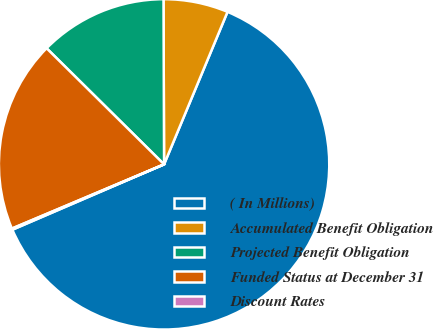Convert chart. <chart><loc_0><loc_0><loc_500><loc_500><pie_chart><fcel>( In Millions)<fcel>Accumulated Benefit Obligation<fcel>Projected Benefit Obligation<fcel>Funded Status at December 31<fcel>Discount Rates<nl><fcel>62.25%<fcel>6.33%<fcel>12.54%<fcel>18.76%<fcel>0.12%<nl></chart> 